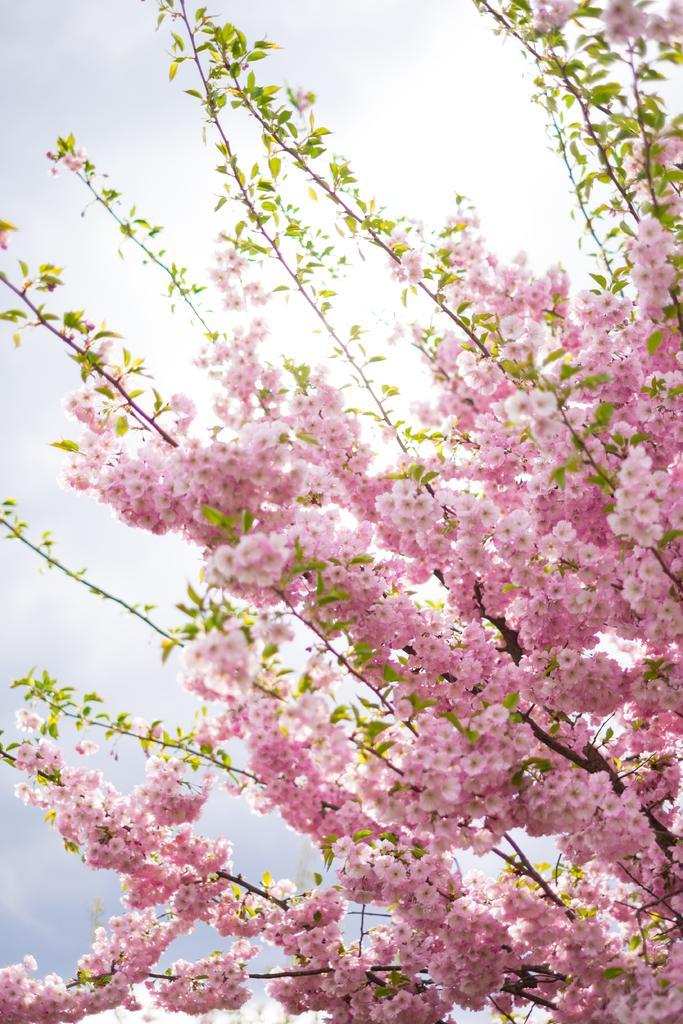Could you give a brief overview of what you see in this image? In this image I can see there are beautiful flowers in pink color to this tree, at the top it is the cloudy sky. 